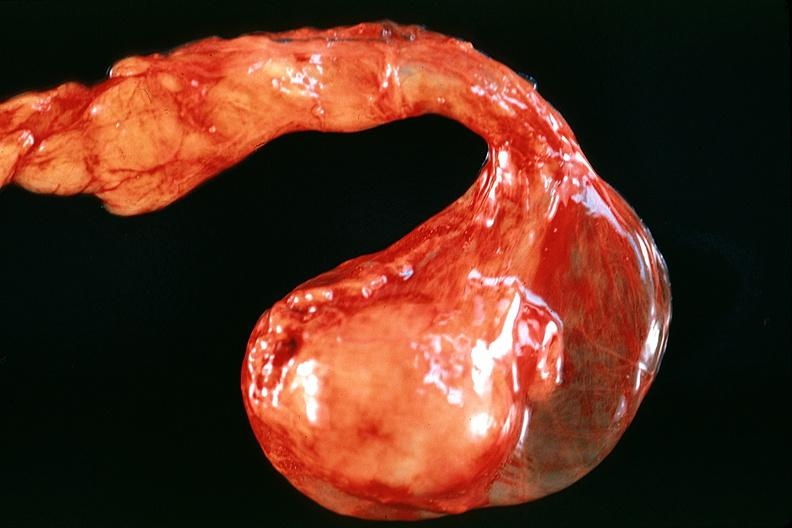s male reproductive present?
Answer the question using a single word or phrase. Yes 